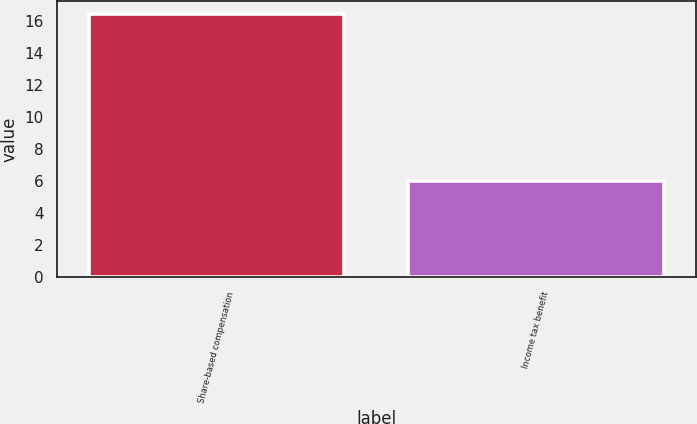<chart> <loc_0><loc_0><loc_500><loc_500><bar_chart><fcel>Share-based compensation<fcel>Income tax benefit<nl><fcel>16.4<fcel>6<nl></chart> 